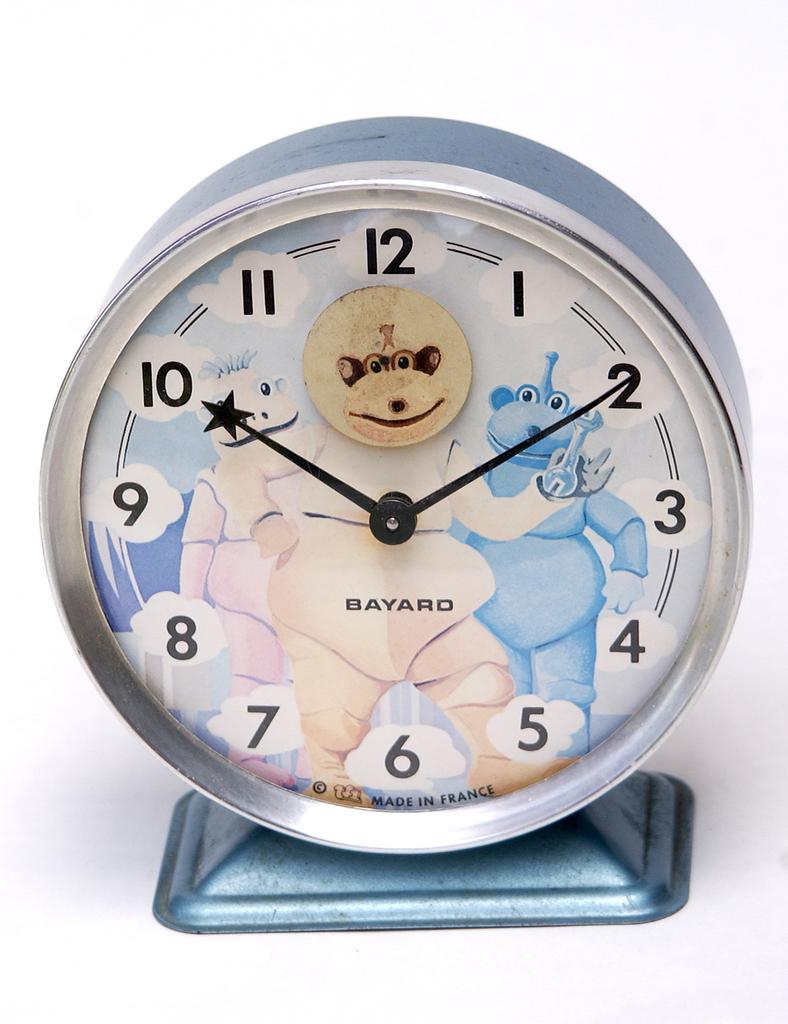<image>
Create a compact narrative representing the image presented. an alarm with all the numbers through 12 on it 